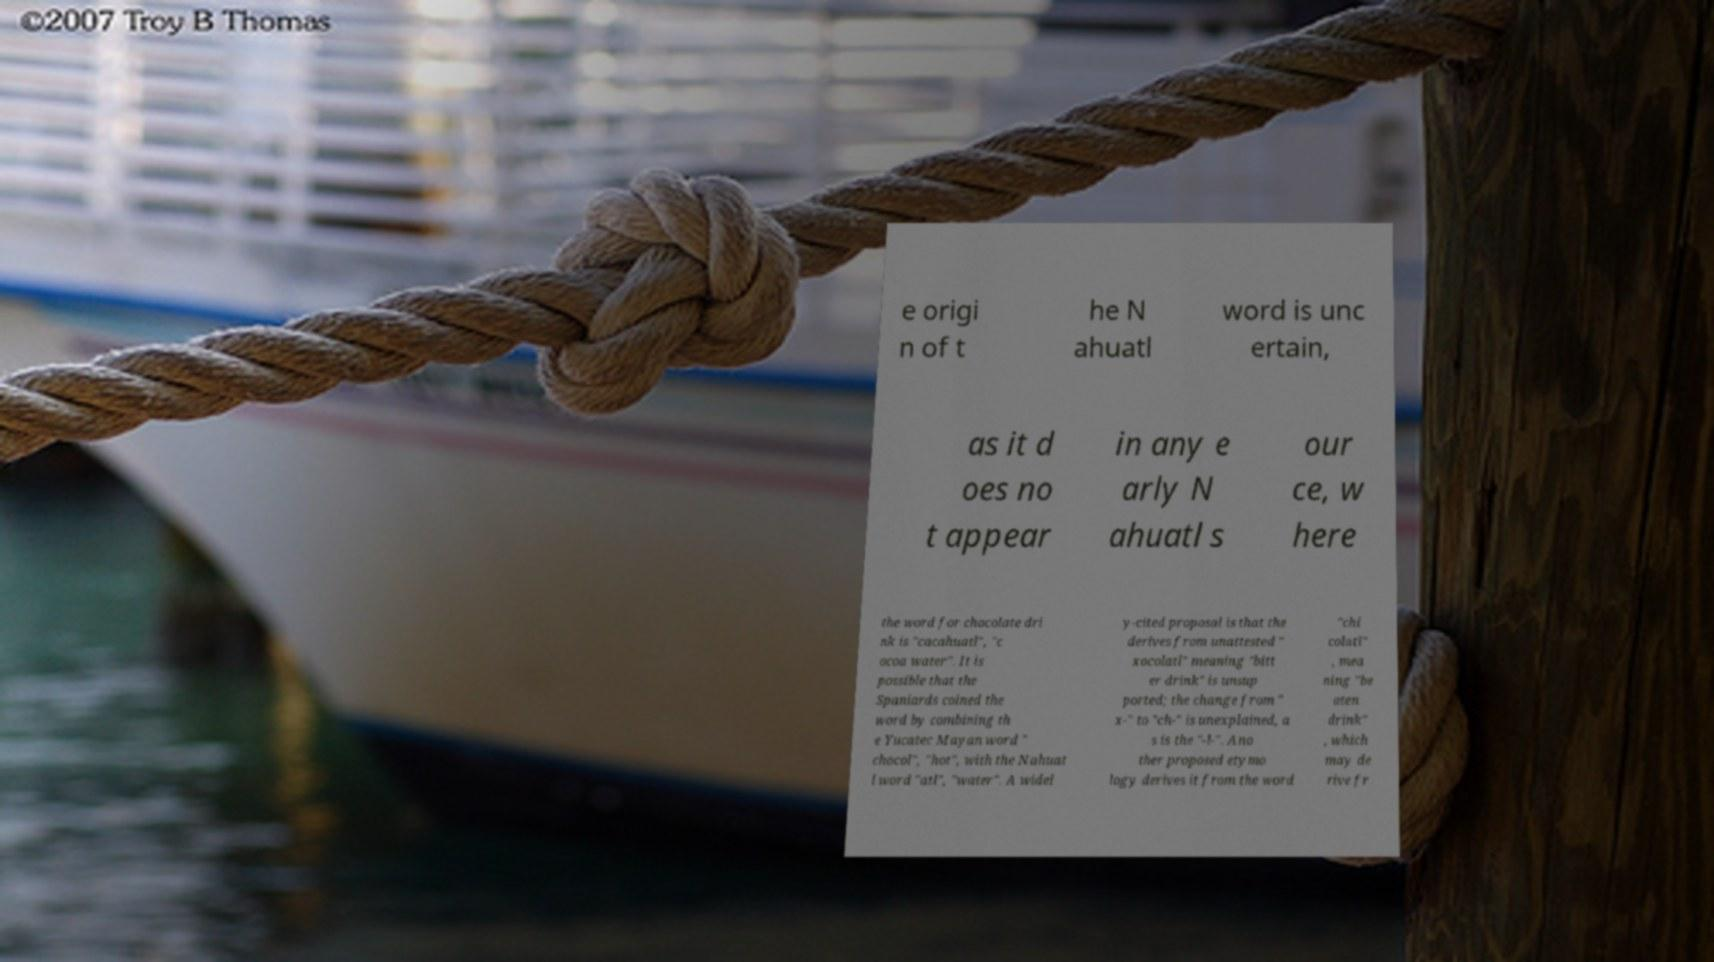Could you assist in decoding the text presented in this image and type it out clearly? e origi n of t he N ahuatl word is unc ertain, as it d oes no t appear in any e arly N ahuatl s our ce, w here the word for chocolate dri nk is "cacahuatl", "c ocoa water". It is possible that the Spaniards coined the word by combining th e Yucatec Mayan word " chocol", "hot", with the Nahuat l word "atl", "water". A widel y-cited proposal is that the derives from unattested " xocolatl" meaning "bitt er drink" is unsup ported; the change from " x-" to "ch-" is unexplained, a s is the "-l-". Ano ther proposed etymo logy derives it from the word "chi colatl" , mea ning "be aten drink" , which may de rive fr 